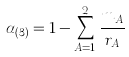<formula> <loc_0><loc_0><loc_500><loc_500>\alpha _ { ( 3 ) } = 1 - \sum _ { A = 1 } ^ { 2 } \frac { m _ { A } } { r _ { A } }</formula> 